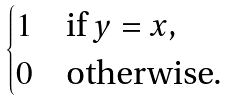<formula> <loc_0><loc_0><loc_500><loc_500>\begin{cases} 1 & \text {if $y = x$,} \\ 0 & \text {otherwise.} \end{cases}</formula> 